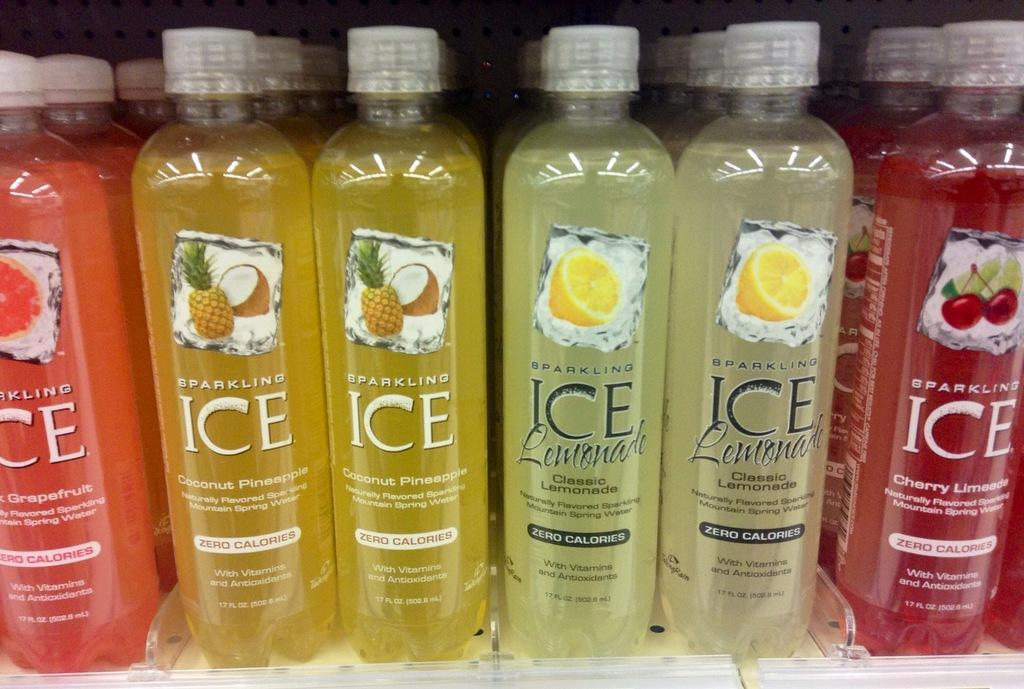<image>
Create a compact narrative representing the image presented. a row of different colors of bottles that are labeled 'ice' 